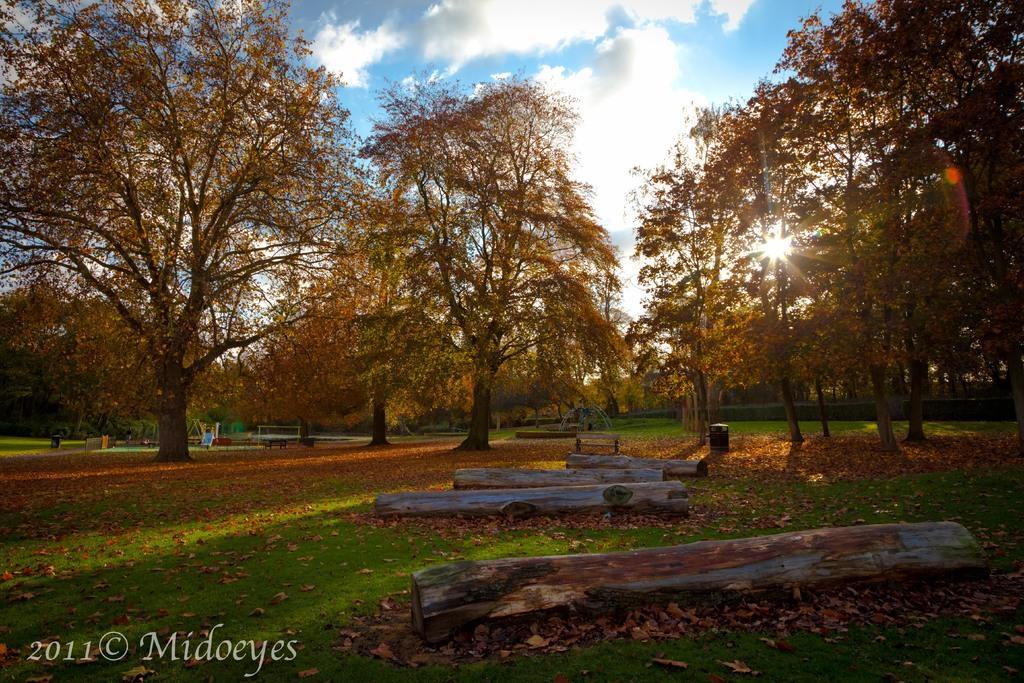Can you describe this image briefly? This picture is clicked outside. In the foreground we can see the trunks of the trees and thee dry leaves lying on the ground and we can see the green grass. In the center we can see the trees and some benches and some other objects. In the background there is a sky with the clouds and we can see the sunlight. At the bottom left corner there is a text on the image. 